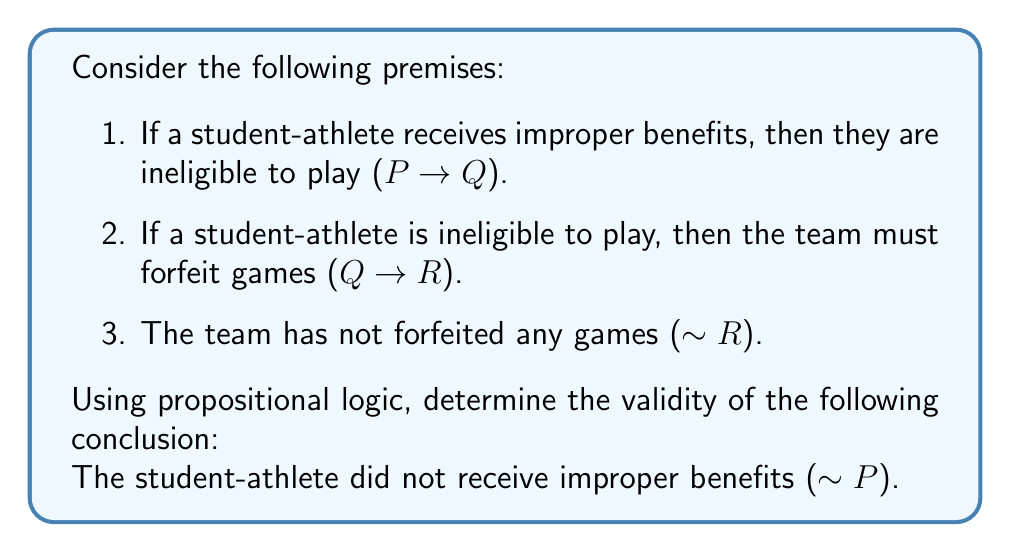What is the answer to this math problem? Let's analyze this argument using propositional logic:

1. We have three premises and a conclusion:
   P: A student-athlete receives improper benefits
   Q: The student-athlete is ineligible to play
   R: The team must forfeit games

   Premise 1: P → Q
   Premise 2: Q → R
   Premise 3: ~R
   Conclusion: ~P

2. This argument form is known as Modus Tollens (denying the consequent). To prove its validity, we'll use a proof by contradiction.

3. Assume the premises are true and the conclusion is false:
   (P → Q) ∧ (Q → R) ∧ ~R ∧ P

4. From P and (P → Q), we can deduce Q using Modus Ponens:
   P
   P → Q
   ∴ Q

5. From Q and (Q → R), we can deduce R using Modus Ponens:
   Q
   Q → R
   ∴ R

6. However, we now have both R and ~R, which is a contradiction.

7. Since assuming the premises are true and the conclusion is false led to a contradiction, we can conclude that the argument is valid.

8. This means that if all the premises are true, the conclusion must also be true.

In the context of athletic eligibility, this logical argument suggests that if a team hasn't forfeited any games, we can validly conclude that no student-athlete on that team has received improper benefits, assuming the premises are true. However, it's important to note that in real-world scenarios, there might be other factors or premises not considered in this simplified logical model.
Answer: The argument is valid. If the premises are true, then the conclusion logically follows. 